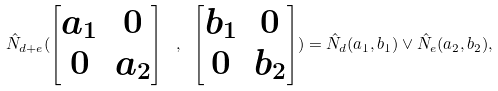<formula> <loc_0><loc_0><loc_500><loc_500>\hat { N } _ { d + e } ( \begin{bmatrix} a _ { 1 } & 0 \\ 0 & a _ { 2 } \end{bmatrix} \ , \ \begin{bmatrix} b _ { 1 } & 0 \\ 0 & b _ { 2 } \end{bmatrix} ) = \hat { N } _ { d } ( a _ { 1 } , b _ { 1 } ) \vee \hat { N } _ { e } ( a _ { 2 } , b _ { 2 } ) ,</formula> 